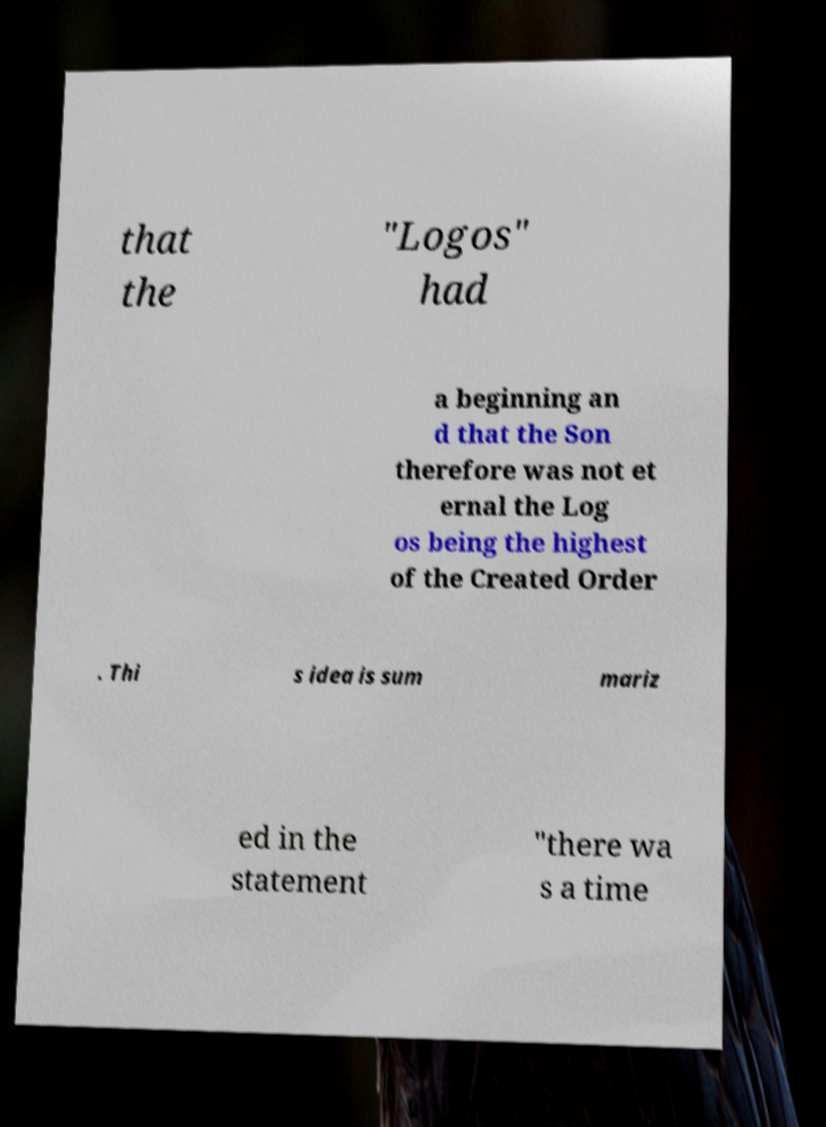Could you assist in decoding the text presented in this image and type it out clearly? that the "Logos" had a beginning an d that the Son therefore was not et ernal the Log os being the highest of the Created Order . Thi s idea is sum mariz ed in the statement "there wa s a time 